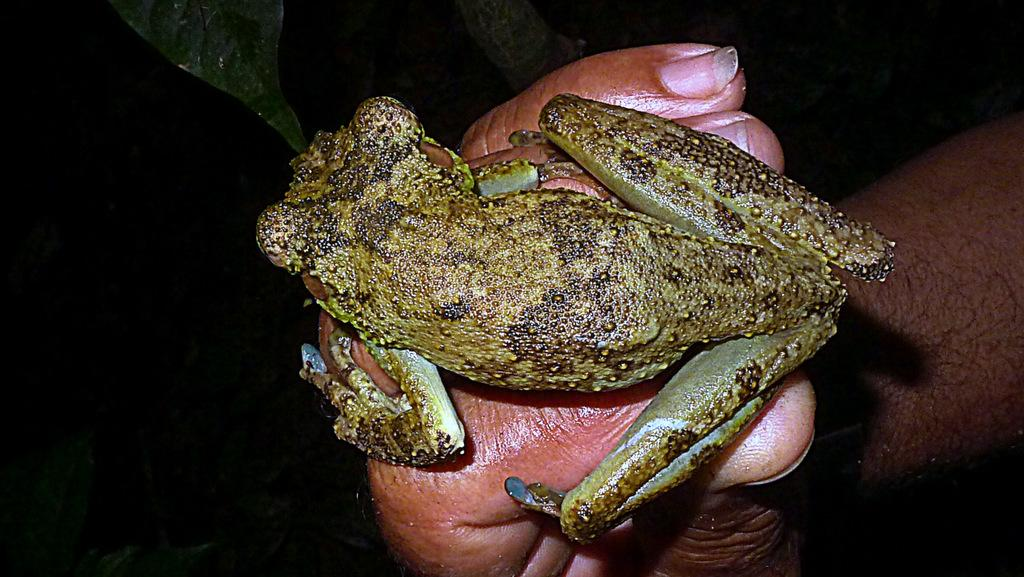What animal is the main subject of the image? There is a frog in the image. Where is the frog located in the image? The frog is on a person's hand. What can be seen in the background of the image? There are leaves in the background of the image. How would you describe the lighting or color of the background? The background of the image has a dark view. How many steel babies are visible in the image? There are no steel babies present in the image. Is there an owl perched on the person's hand next to the frog? No, there is no owl present in the image; only the frog is visible on the person's hand. 